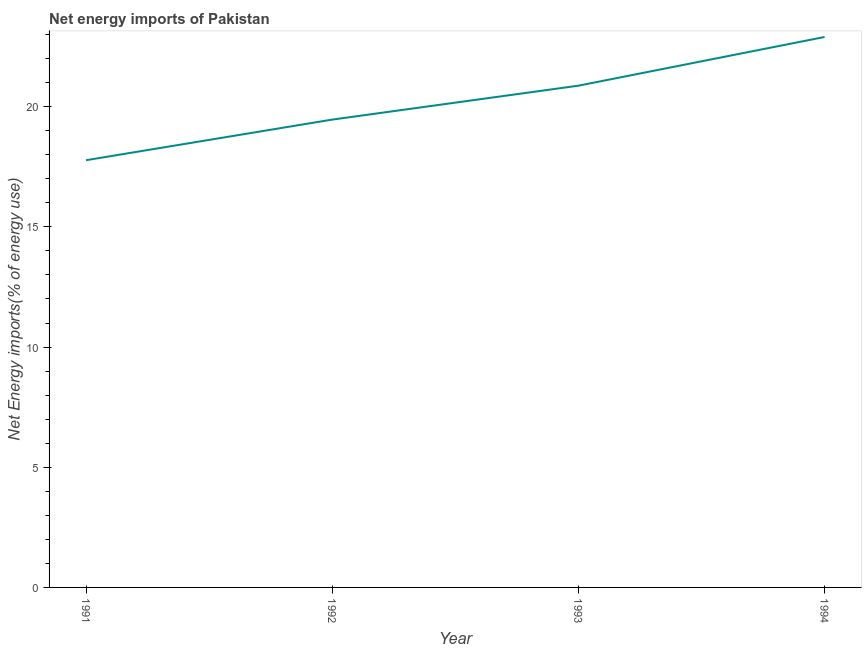What is the energy imports in 1994?
Provide a short and direct response. 22.9. Across all years, what is the maximum energy imports?
Offer a very short reply. 22.9. Across all years, what is the minimum energy imports?
Ensure brevity in your answer.  17.77. In which year was the energy imports minimum?
Your answer should be compact. 1991. What is the sum of the energy imports?
Provide a succinct answer. 81.01. What is the difference between the energy imports in 1991 and 1992?
Ensure brevity in your answer.  -1.69. What is the average energy imports per year?
Make the answer very short. 20.25. What is the median energy imports?
Keep it short and to the point. 20.17. Do a majority of the years between 1993 and 1994 (inclusive) have energy imports greater than 19 %?
Your answer should be very brief. Yes. What is the ratio of the energy imports in 1992 to that in 1993?
Make the answer very short. 0.93. Is the difference between the energy imports in 1991 and 1994 greater than the difference between any two years?
Make the answer very short. Yes. What is the difference between the highest and the second highest energy imports?
Your answer should be very brief. 2.03. Is the sum of the energy imports in 1993 and 1994 greater than the maximum energy imports across all years?
Provide a succinct answer. Yes. What is the difference between the highest and the lowest energy imports?
Keep it short and to the point. 5.13. In how many years, is the energy imports greater than the average energy imports taken over all years?
Keep it short and to the point. 2. Does the energy imports monotonically increase over the years?
Ensure brevity in your answer.  Yes. Does the graph contain grids?
Provide a succinct answer. No. What is the title of the graph?
Your response must be concise. Net energy imports of Pakistan. What is the label or title of the Y-axis?
Make the answer very short. Net Energy imports(% of energy use). What is the Net Energy imports(% of energy use) of 1991?
Keep it short and to the point. 17.77. What is the Net Energy imports(% of energy use) in 1992?
Give a very brief answer. 19.46. What is the Net Energy imports(% of energy use) in 1993?
Provide a short and direct response. 20.87. What is the Net Energy imports(% of energy use) in 1994?
Offer a very short reply. 22.9. What is the difference between the Net Energy imports(% of energy use) in 1991 and 1992?
Your answer should be very brief. -1.69. What is the difference between the Net Energy imports(% of energy use) in 1991 and 1993?
Your answer should be very brief. -3.1. What is the difference between the Net Energy imports(% of energy use) in 1991 and 1994?
Your response must be concise. -5.13. What is the difference between the Net Energy imports(% of energy use) in 1992 and 1993?
Give a very brief answer. -1.41. What is the difference between the Net Energy imports(% of energy use) in 1992 and 1994?
Offer a very short reply. -3.44. What is the difference between the Net Energy imports(% of energy use) in 1993 and 1994?
Provide a short and direct response. -2.03. What is the ratio of the Net Energy imports(% of energy use) in 1991 to that in 1992?
Your response must be concise. 0.91. What is the ratio of the Net Energy imports(% of energy use) in 1991 to that in 1993?
Provide a short and direct response. 0.85. What is the ratio of the Net Energy imports(% of energy use) in 1991 to that in 1994?
Ensure brevity in your answer.  0.78. What is the ratio of the Net Energy imports(% of energy use) in 1992 to that in 1993?
Offer a very short reply. 0.93. What is the ratio of the Net Energy imports(% of energy use) in 1993 to that in 1994?
Your answer should be very brief. 0.91. 